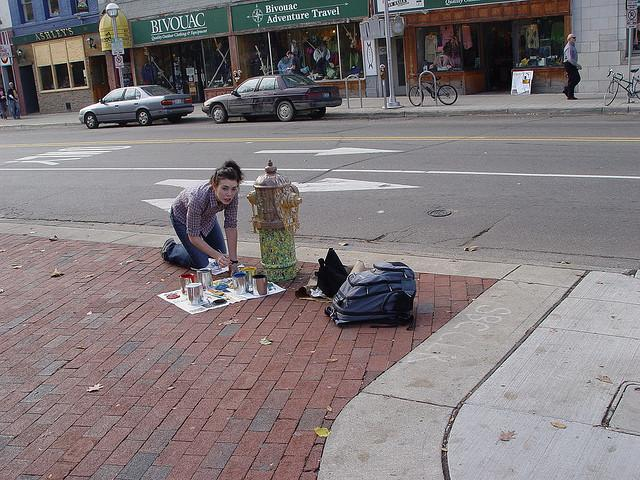What is the woman doing to the fire hydrant?

Choices:
A) cleaning it
B) building it
C) painting it
D) dismantling it painting it 